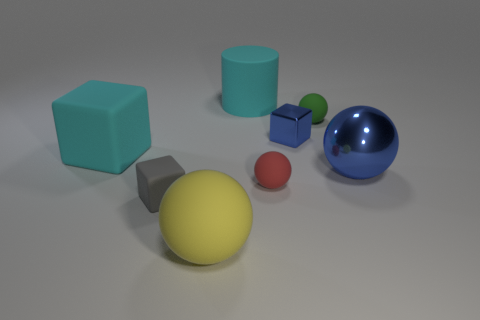Is the number of tiny shiny things that are to the left of the large blue shiny object greater than the number of metal blocks to the left of the large cyan matte cube?
Provide a succinct answer. Yes. There is a ball that is the same size as the red object; what color is it?
Provide a succinct answer. Green. Is there a shiny cylinder that has the same color as the large shiny object?
Your response must be concise. No. Do the big ball that is left of the cyan cylinder and the small cube that is to the left of the cyan cylinder have the same color?
Provide a short and direct response. No. There is a blue thing that is left of the big metallic object; what is it made of?
Give a very brief answer. Metal. What color is the cylinder that is made of the same material as the red sphere?
Keep it short and to the point. Cyan. What number of green objects are the same size as the blue cube?
Your response must be concise. 1. There is a matte sphere that is behind the blue metallic block; is it the same size as the large cylinder?
Your response must be concise. No. What shape is the large matte thing that is in front of the small green matte object and behind the yellow matte thing?
Give a very brief answer. Cube. Are there any large rubber blocks in front of the large cyan rubber cube?
Your response must be concise. No. 